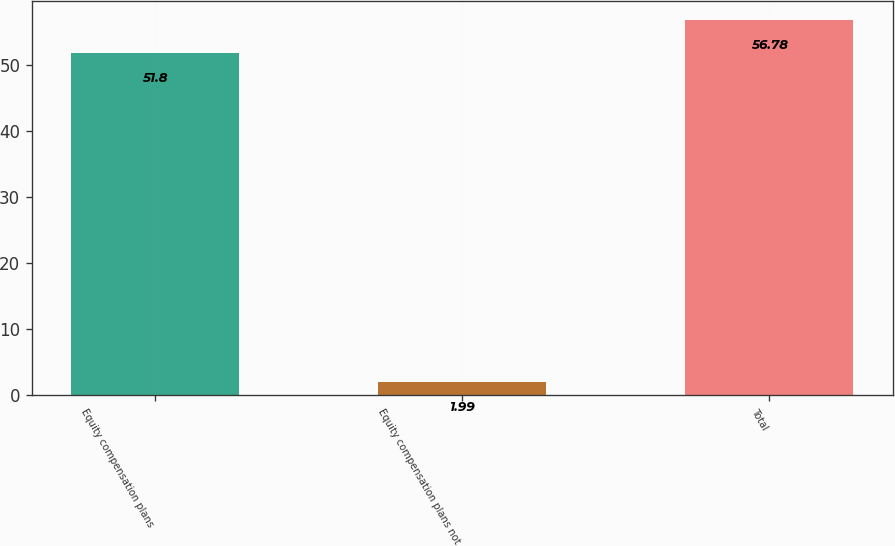Convert chart. <chart><loc_0><loc_0><loc_500><loc_500><bar_chart><fcel>Equity compensation plans<fcel>Equity compensation plans not<fcel>Total<nl><fcel>51.8<fcel>1.99<fcel>56.78<nl></chart> 